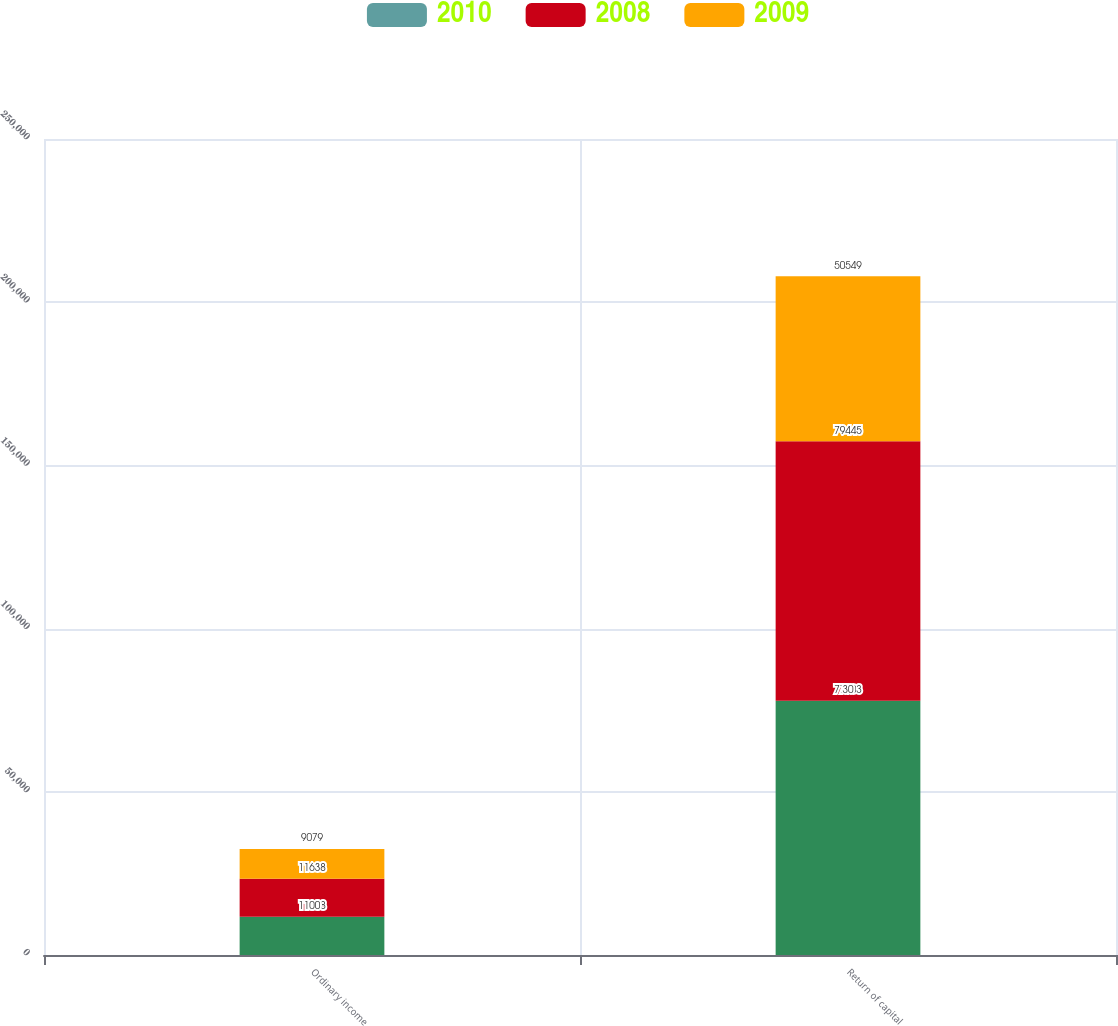<chart> <loc_0><loc_0><loc_500><loc_500><stacked_bar_chart><ecel><fcel>Ordinary income<fcel>Return of capital<nl><fcel>nan<fcel>11638<fcel>77903<nl><fcel>2010<fcel>100<fcel>30<nl><fcel>2008<fcel>11638<fcel>79445<nl><fcel>2009<fcel>9079<fcel>50549<nl></chart> 